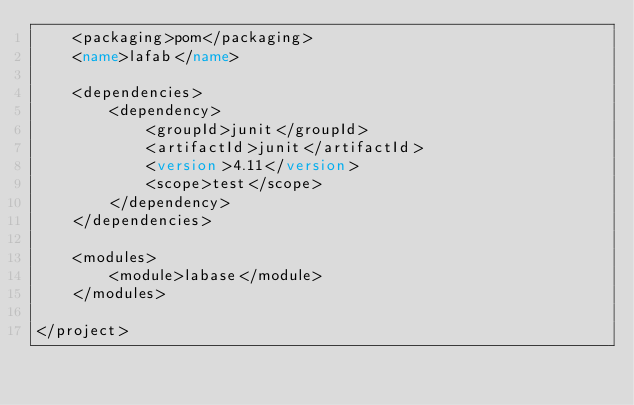<code> <loc_0><loc_0><loc_500><loc_500><_XML_>    <packaging>pom</packaging>
    <name>lafab</name>

    <dependencies>
        <dependency>
            <groupId>junit</groupId>
            <artifactId>junit</artifactId>
            <version>4.11</version>
            <scope>test</scope>
        </dependency>
    </dependencies>

    <modules>
        <module>labase</module>
    </modules>

</project></code> 